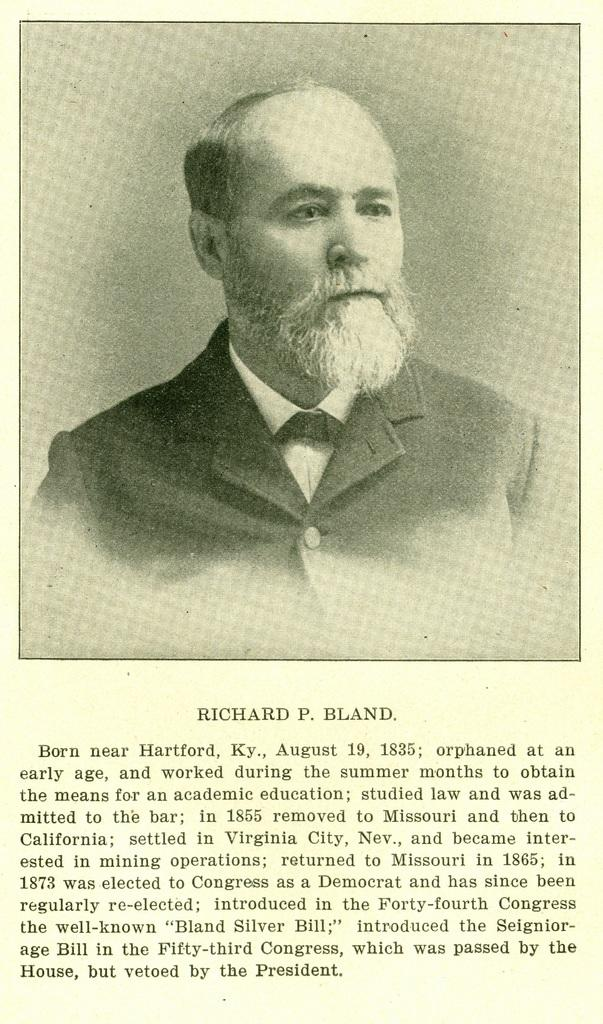What is the main subject of the image? There is a person in the image. What is the color scheme of the image? The image is black and white. Can you describe any text present in the image? There is text in the image, written in black color and located under the person. How many wheels can be seen in the image? There are no wheels present in the image. What type of key is used to unlock the cellar in the image? There is no cellar or key present in the image. 